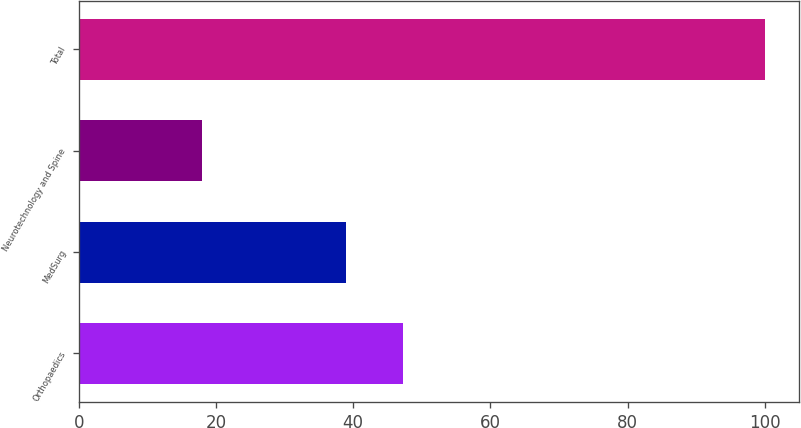Convert chart. <chart><loc_0><loc_0><loc_500><loc_500><bar_chart><fcel>Orthopaedics<fcel>MedSurg<fcel>Neurotechnology and Spine<fcel>Total<nl><fcel>47.2<fcel>39<fcel>18<fcel>100<nl></chart> 